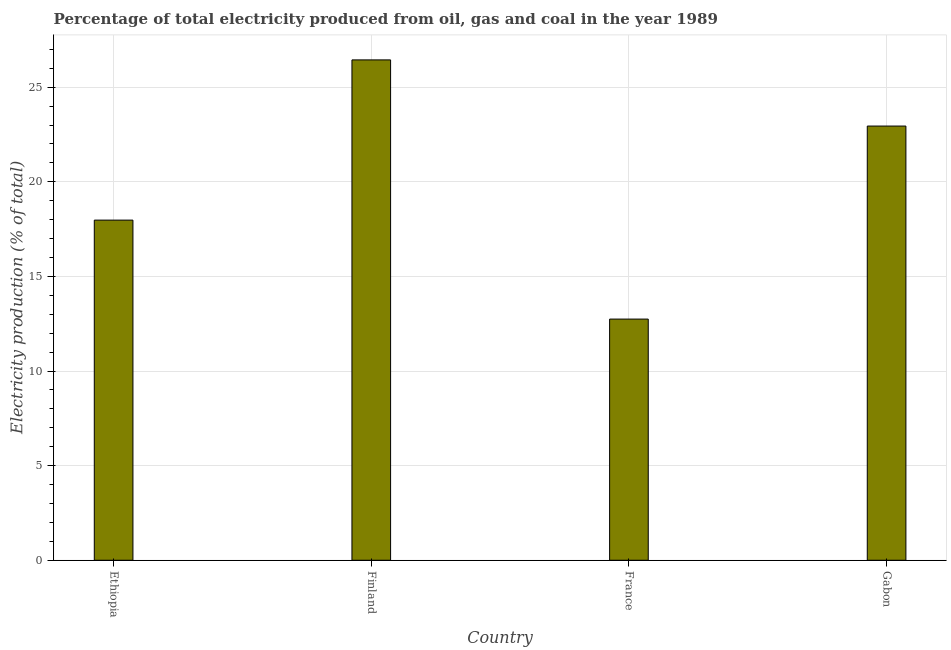What is the title of the graph?
Provide a succinct answer. Percentage of total electricity produced from oil, gas and coal in the year 1989. What is the label or title of the X-axis?
Offer a very short reply. Country. What is the label or title of the Y-axis?
Offer a terse response. Electricity production (% of total). What is the electricity production in Finland?
Your response must be concise. 26.44. Across all countries, what is the maximum electricity production?
Provide a succinct answer. 26.44. Across all countries, what is the minimum electricity production?
Ensure brevity in your answer.  12.74. In which country was the electricity production maximum?
Offer a very short reply. Finland. What is the sum of the electricity production?
Ensure brevity in your answer.  80.11. What is the difference between the electricity production in Ethiopia and Gabon?
Your answer should be very brief. -4.97. What is the average electricity production per country?
Provide a succinct answer. 20.03. What is the median electricity production?
Make the answer very short. 20.46. In how many countries, is the electricity production greater than 12 %?
Make the answer very short. 4. What is the ratio of the electricity production in Ethiopia to that in Gabon?
Offer a terse response. 0.78. What is the difference between the highest and the second highest electricity production?
Keep it short and to the point. 3.5. Is the sum of the electricity production in Finland and Gabon greater than the maximum electricity production across all countries?
Your response must be concise. Yes. In how many countries, is the electricity production greater than the average electricity production taken over all countries?
Offer a very short reply. 2. How many bars are there?
Give a very brief answer. 4. Are all the bars in the graph horizontal?
Provide a short and direct response. No. What is the difference between two consecutive major ticks on the Y-axis?
Your response must be concise. 5. Are the values on the major ticks of Y-axis written in scientific E-notation?
Make the answer very short. No. What is the Electricity production (% of total) of Ethiopia?
Your answer should be very brief. 17.97. What is the Electricity production (% of total) of Finland?
Provide a succinct answer. 26.44. What is the Electricity production (% of total) of France?
Make the answer very short. 12.74. What is the Electricity production (% of total) of Gabon?
Ensure brevity in your answer.  22.95. What is the difference between the Electricity production (% of total) in Ethiopia and Finland?
Offer a terse response. -8.47. What is the difference between the Electricity production (% of total) in Ethiopia and France?
Make the answer very short. 5.23. What is the difference between the Electricity production (% of total) in Ethiopia and Gabon?
Keep it short and to the point. -4.97. What is the difference between the Electricity production (% of total) in Finland and France?
Provide a succinct answer. 13.7. What is the difference between the Electricity production (% of total) in Finland and Gabon?
Give a very brief answer. 3.5. What is the difference between the Electricity production (% of total) in France and Gabon?
Give a very brief answer. -10.2. What is the ratio of the Electricity production (% of total) in Ethiopia to that in Finland?
Keep it short and to the point. 0.68. What is the ratio of the Electricity production (% of total) in Ethiopia to that in France?
Give a very brief answer. 1.41. What is the ratio of the Electricity production (% of total) in Ethiopia to that in Gabon?
Keep it short and to the point. 0.78. What is the ratio of the Electricity production (% of total) in Finland to that in France?
Make the answer very short. 2.08. What is the ratio of the Electricity production (% of total) in Finland to that in Gabon?
Your answer should be compact. 1.15. What is the ratio of the Electricity production (% of total) in France to that in Gabon?
Offer a very short reply. 0.56. 